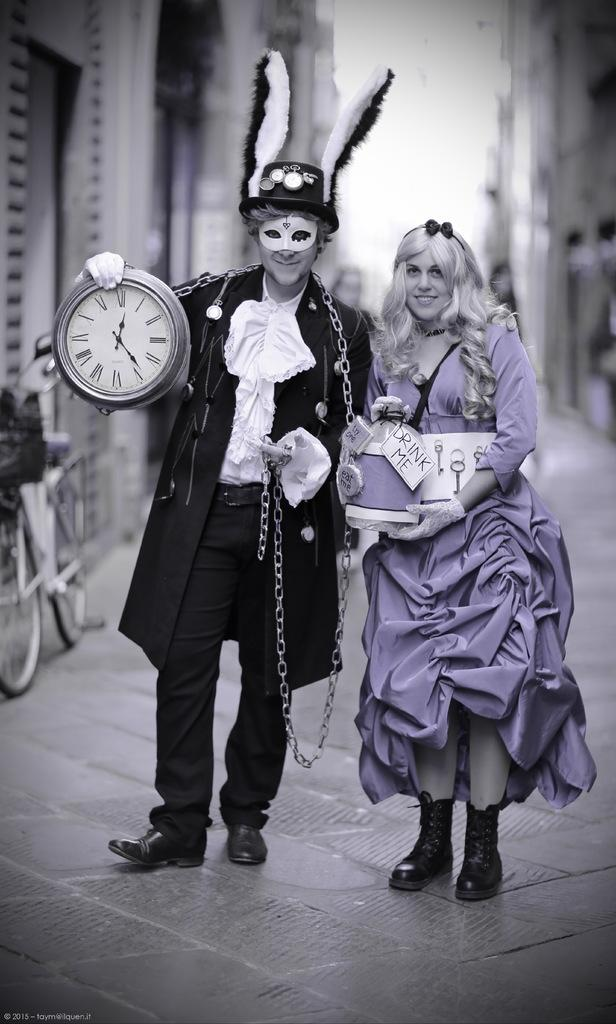<image>
Give a short and clear explanation of the subsequent image. Two people dressed in costumes, one holding a sign reading 'drink me.' 